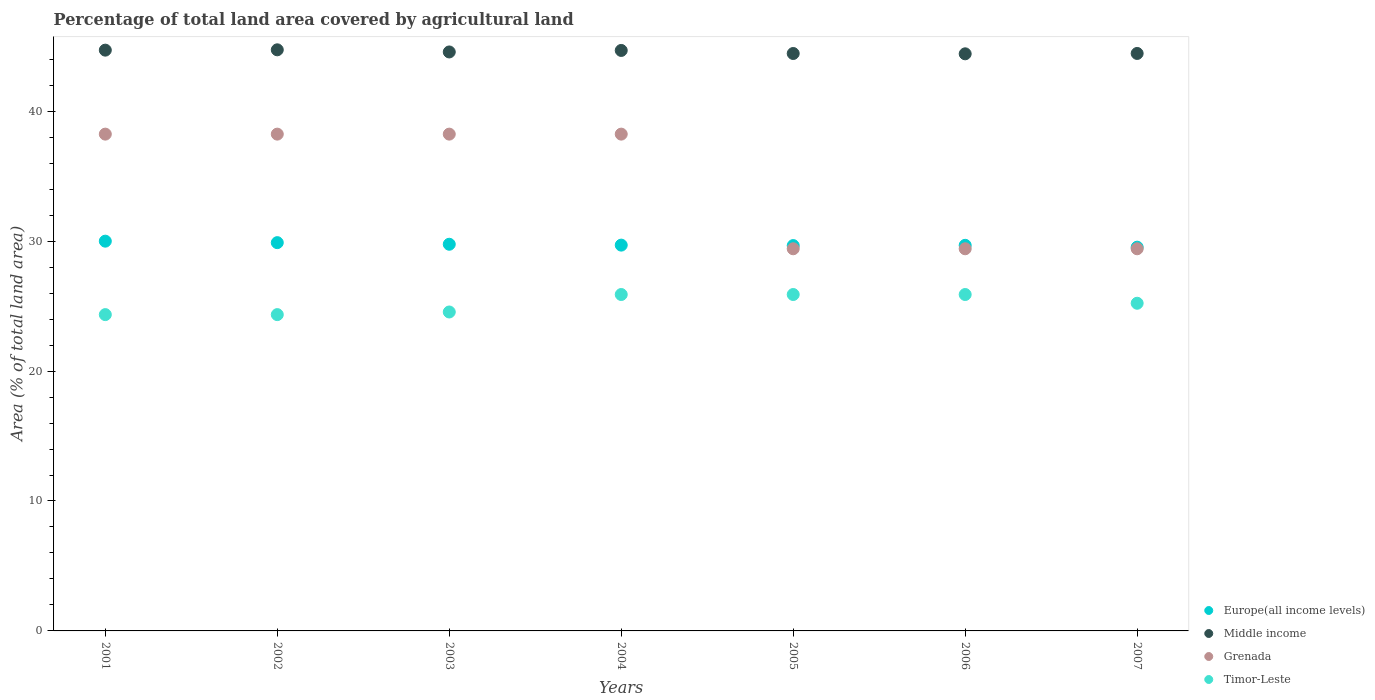How many different coloured dotlines are there?
Keep it short and to the point. 4. Is the number of dotlines equal to the number of legend labels?
Offer a very short reply. Yes. What is the percentage of agricultural land in Europe(all income levels) in 2001?
Give a very brief answer. 30. Across all years, what is the maximum percentage of agricultural land in Europe(all income levels)?
Offer a very short reply. 30. Across all years, what is the minimum percentage of agricultural land in Timor-Leste?
Offer a very short reply. 24.34. In which year was the percentage of agricultural land in Timor-Leste maximum?
Offer a very short reply. 2004. What is the total percentage of agricultural land in Grenada in the graph?
Your answer should be compact. 241.18. What is the difference between the percentage of agricultural land in Middle income in 2003 and that in 2006?
Provide a short and direct response. 0.14. What is the difference between the percentage of agricultural land in Grenada in 2006 and the percentage of agricultural land in Middle income in 2007?
Keep it short and to the point. -15.03. What is the average percentage of agricultural land in Middle income per year?
Keep it short and to the point. 44.57. In the year 2001, what is the difference between the percentage of agricultural land in Grenada and percentage of agricultural land in Europe(all income levels)?
Ensure brevity in your answer.  8.24. What is the ratio of the percentage of agricultural land in Timor-Leste in 2005 to that in 2007?
Offer a very short reply. 1.03. What is the difference between the highest and the second highest percentage of agricultural land in Middle income?
Your answer should be compact. 0.03. What is the difference between the highest and the lowest percentage of agricultural land in Middle income?
Your answer should be compact. 0.31. Is the sum of the percentage of agricultural land in Europe(all income levels) in 2003 and 2007 greater than the maximum percentage of agricultural land in Grenada across all years?
Offer a terse response. Yes. Does the percentage of agricultural land in Middle income monotonically increase over the years?
Ensure brevity in your answer.  No. Is the percentage of agricultural land in Middle income strictly greater than the percentage of agricultural land in Grenada over the years?
Offer a terse response. Yes. Is the percentage of agricultural land in Middle income strictly less than the percentage of agricultural land in Timor-Leste over the years?
Offer a terse response. No. How many years are there in the graph?
Provide a succinct answer. 7. What is the difference between two consecutive major ticks on the Y-axis?
Offer a terse response. 10. Are the values on the major ticks of Y-axis written in scientific E-notation?
Offer a very short reply. No. Where does the legend appear in the graph?
Provide a short and direct response. Bottom right. How many legend labels are there?
Your answer should be very brief. 4. What is the title of the graph?
Your response must be concise. Percentage of total land area covered by agricultural land. What is the label or title of the Y-axis?
Give a very brief answer. Area (% of total land area). What is the Area (% of total land area) of Europe(all income levels) in 2001?
Your answer should be compact. 30. What is the Area (% of total land area) in Middle income in 2001?
Make the answer very short. 44.7. What is the Area (% of total land area) of Grenada in 2001?
Offer a terse response. 38.24. What is the Area (% of total land area) in Timor-Leste in 2001?
Provide a succinct answer. 24.34. What is the Area (% of total land area) in Europe(all income levels) in 2002?
Make the answer very short. 29.88. What is the Area (% of total land area) of Middle income in 2002?
Provide a succinct answer. 44.72. What is the Area (% of total land area) in Grenada in 2002?
Keep it short and to the point. 38.24. What is the Area (% of total land area) in Timor-Leste in 2002?
Offer a very short reply. 24.34. What is the Area (% of total land area) in Europe(all income levels) in 2003?
Make the answer very short. 29.76. What is the Area (% of total land area) in Middle income in 2003?
Your answer should be very brief. 44.56. What is the Area (% of total land area) of Grenada in 2003?
Keep it short and to the point. 38.24. What is the Area (% of total land area) in Timor-Leste in 2003?
Keep it short and to the point. 24.55. What is the Area (% of total land area) in Europe(all income levels) in 2004?
Ensure brevity in your answer.  29.69. What is the Area (% of total land area) of Middle income in 2004?
Your answer should be compact. 44.68. What is the Area (% of total land area) of Grenada in 2004?
Provide a short and direct response. 38.24. What is the Area (% of total land area) of Timor-Leste in 2004?
Provide a short and direct response. 25.89. What is the Area (% of total land area) of Europe(all income levels) in 2005?
Offer a terse response. 29.66. What is the Area (% of total land area) in Middle income in 2005?
Offer a very short reply. 44.44. What is the Area (% of total land area) of Grenada in 2005?
Provide a short and direct response. 29.41. What is the Area (% of total land area) in Timor-Leste in 2005?
Keep it short and to the point. 25.89. What is the Area (% of total land area) in Europe(all income levels) in 2006?
Your answer should be very brief. 29.68. What is the Area (% of total land area) in Middle income in 2006?
Your response must be concise. 44.42. What is the Area (% of total land area) of Grenada in 2006?
Offer a terse response. 29.41. What is the Area (% of total land area) in Timor-Leste in 2006?
Provide a short and direct response. 25.89. What is the Area (% of total land area) of Europe(all income levels) in 2007?
Provide a succinct answer. 29.53. What is the Area (% of total land area) in Middle income in 2007?
Provide a succinct answer. 44.44. What is the Area (% of total land area) in Grenada in 2007?
Make the answer very short. 29.41. What is the Area (% of total land area) of Timor-Leste in 2007?
Offer a terse response. 25.22. Across all years, what is the maximum Area (% of total land area) in Europe(all income levels)?
Your answer should be very brief. 30. Across all years, what is the maximum Area (% of total land area) of Middle income?
Your answer should be very brief. 44.72. Across all years, what is the maximum Area (% of total land area) in Grenada?
Offer a terse response. 38.24. Across all years, what is the maximum Area (% of total land area) in Timor-Leste?
Make the answer very short. 25.89. Across all years, what is the minimum Area (% of total land area) of Europe(all income levels)?
Provide a short and direct response. 29.53. Across all years, what is the minimum Area (% of total land area) of Middle income?
Offer a terse response. 44.42. Across all years, what is the minimum Area (% of total land area) in Grenada?
Your answer should be compact. 29.41. Across all years, what is the minimum Area (% of total land area) of Timor-Leste?
Provide a short and direct response. 24.34. What is the total Area (% of total land area) of Europe(all income levels) in the graph?
Ensure brevity in your answer.  208.2. What is the total Area (% of total land area) in Middle income in the graph?
Your answer should be compact. 311.96. What is the total Area (% of total land area) in Grenada in the graph?
Offer a terse response. 241.18. What is the total Area (% of total land area) of Timor-Leste in the graph?
Make the answer very short. 176.13. What is the difference between the Area (% of total land area) of Europe(all income levels) in 2001 and that in 2002?
Make the answer very short. 0.11. What is the difference between the Area (% of total land area) of Middle income in 2001 and that in 2002?
Offer a terse response. -0.03. What is the difference between the Area (% of total land area) of Grenada in 2001 and that in 2002?
Provide a succinct answer. 0. What is the difference between the Area (% of total land area) of Timor-Leste in 2001 and that in 2002?
Your answer should be compact. 0. What is the difference between the Area (% of total land area) of Europe(all income levels) in 2001 and that in 2003?
Give a very brief answer. 0.24. What is the difference between the Area (% of total land area) of Middle income in 2001 and that in 2003?
Offer a very short reply. 0.14. What is the difference between the Area (% of total land area) of Grenada in 2001 and that in 2003?
Your response must be concise. 0. What is the difference between the Area (% of total land area) in Timor-Leste in 2001 and that in 2003?
Offer a terse response. -0.2. What is the difference between the Area (% of total land area) in Europe(all income levels) in 2001 and that in 2004?
Your answer should be compact. 0.3. What is the difference between the Area (% of total land area) in Middle income in 2001 and that in 2004?
Offer a very short reply. 0.02. What is the difference between the Area (% of total land area) of Grenada in 2001 and that in 2004?
Keep it short and to the point. 0. What is the difference between the Area (% of total land area) in Timor-Leste in 2001 and that in 2004?
Give a very brief answer. -1.55. What is the difference between the Area (% of total land area) in Europe(all income levels) in 2001 and that in 2005?
Give a very brief answer. 0.34. What is the difference between the Area (% of total land area) in Middle income in 2001 and that in 2005?
Give a very brief answer. 0.26. What is the difference between the Area (% of total land area) in Grenada in 2001 and that in 2005?
Your answer should be compact. 8.82. What is the difference between the Area (% of total land area) in Timor-Leste in 2001 and that in 2005?
Keep it short and to the point. -1.55. What is the difference between the Area (% of total land area) in Europe(all income levels) in 2001 and that in 2006?
Offer a very short reply. 0.32. What is the difference between the Area (% of total land area) of Middle income in 2001 and that in 2006?
Offer a very short reply. 0.28. What is the difference between the Area (% of total land area) of Grenada in 2001 and that in 2006?
Your response must be concise. 8.82. What is the difference between the Area (% of total land area) in Timor-Leste in 2001 and that in 2006?
Provide a short and direct response. -1.55. What is the difference between the Area (% of total land area) of Europe(all income levels) in 2001 and that in 2007?
Provide a short and direct response. 0.46. What is the difference between the Area (% of total land area) in Middle income in 2001 and that in 2007?
Your response must be concise. 0.25. What is the difference between the Area (% of total land area) of Grenada in 2001 and that in 2007?
Ensure brevity in your answer.  8.82. What is the difference between the Area (% of total land area) of Timor-Leste in 2001 and that in 2007?
Provide a succinct answer. -0.87. What is the difference between the Area (% of total land area) of Europe(all income levels) in 2002 and that in 2003?
Offer a terse response. 0.12. What is the difference between the Area (% of total land area) of Middle income in 2002 and that in 2003?
Make the answer very short. 0.16. What is the difference between the Area (% of total land area) of Grenada in 2002 and that in 2003?
Provide a succinct answer. 0. What is the difference between the Area (% of total land area) in Timor-Leste in 2002 and that in 2003?
Keep it short and to the point. -0.2. What is the difference between the Area (% of total land area) of Europe(all income levels) in 2002 and that in 2004?
Give a very brief answer. 0.19. What is the difference between the Area (% of total land area) of Middle income in 2002 and that in 2004?
Keep it short and to the point. 0.05. What is the difference between the Area (% of total land area) of Grenada in 2002 and that in 2004?
Ensure brevity in your answer.  0. What is the difference between the Area (% of total land area) of Timor-Leste in 2002 and that in 2004?
Offer a very short reply. -1.55. What is the difference between the Area (% of total land area) of Europe(all income levels) in 2002 and that in 2005?
Provide a succinct answer. 0.23. What is the difference between the Area (% of total land area) in Middle income in 2002 and that in 2005?
Give a very brief answer. 0.28. What is the difference between the Area (% of total land area) in Grenada in 2002 and that in 2005?
Keep it short and to the point. 8.82. What is the difference between the Area (% of total land area) of Timor-Leste in 2002 and that in 2005?
Keep it short and to the point. -1.55. What is the difference between the Area (% of total land area) in Europe(all income levels) in 2002 and that in 2006?
Your response must be concise. 0.21. What is the difference between the Area (% of total land area) of Middle income in 2002 and that in 2006?
Your answer should be very brief. 0.31. What is the difference between the Area (% of total land area) in Grenada in 2002 and that in 2006?
Keep it short and to the point. 8.82. What is the difference between the Area (% of total land area) in Timor-Leste in 2002 and that in 2006?
Offer a very short reply. -1.55. What is the difference between the Area (% of total land area) of Europe(all income levels) in 2002 and that in 2007?
Your response must be concise. 0.35. What is the difference between the Area (% of total land area) in Middle income in 2002 and that in 2007?
Offer a terse response. 0.28. What is the difference between the Area (% of total land area) of Grenada in 2002 and that in 2007?
Your answer should be compact. 8.82. What is the difference between the Area (% of total land area) in Timor-Leste in 2002 and that in 2007?
Provide a succinct answer. -0.87. What is the difference between the Area (% of total land area) of Europe(all income levels) in 2003 and that in 2004?
Your answer should be very brief. 0.07. What is the difference between the Area (% of total land area) of Middle income in 2003 and that in 2004?
Ensure brevity in your answer.  -0.12. What is the difference between the Area (% of total land area) in Timor-Leste in 2003 and that in 2004?
Provide a succinct answer. -1.34. What is the difference between the Area (% of total land area) of Europe(all income levels) in 2003 and that in 2005?
Keep it short and to the point. 0.1. What is the difference between the Area (% of total land area) in Middle income in 2003 and that in 2005?
Offer a terse response. 0.12. What is the difference between the Area (% of total land area) in Grenada in 2003 and that in 2005?
Your response must be concise. 8.82. What is the difference between the Area (% of total land area) in Timor-Leste in 2003 and that in 2005?
Your answer should be compact. -1.34. What is the difference between the Area (% of total land area) in Europe(all income levels) in 2003 and that in 2006?
Offer a very short reply. 0.08. What is the difference between the Area (% of total land area) in Middle income in 2003 and that in 2006?
Keep it short and to the point. 0.14. What is the difference between the Area (% of total land area) in Grenada in 2003 and that in 2006?
Ensure brevity in your answer.  8.82. What is the difference between the Area (% of total land area) in Timor-Leste in 2003 and that in 2006?
Offer a terse response. -1.34. What is the difference between the Area (% of total land area) in Europe(all income levels) in 2003 and that in 2007?
Your response must be concise. 0.23. What is the difference between the Area (% of total land area) of Middle income in 2003 and that in 2007?
Ensure brevity in your answer.  0.12. What is the difference between the Area (% of total land area) in Grenada in 2003 and that in 2007?
Provide a succinct answer. 8.82. What is the difference between the Area (% of total land area) of Timor-Leste in 2003 and that in 2007?
Your answer should be very brief. -0.67. What is the difference between the Area (% of total land area) of Europe(all income levels) in 2004 and that in 2005?
Your answer should be very brief. 0.04. What is the difference between the Area (% of total land area) in Middle income in 2004 and that in 2005?
Provide a short and direct response. 0.24. What is the difference between the Area (% of total land area) in Grenada in 2004 and that in 2005?
Ensure brevity in your answer.  8.82. What is the difference between the Area (% of total land area) of Timor-Leste in 2004 and that in 2005?
Give a very brief answer. 0. What is the difference between the Area (% of total land area) of Europe(all income levels) in 2004 and that in 2006?
Ensure brevity in your answer.  0.02. What is the difference between the Area (% of total land area) in Middle income in 2004 and that in 2006?
Your answer should be very brief. 0.26. What is the difference between the Area (% of total land area) of Grenada in 2004 and that in 2006?
Give a very brief answer. 8.82. What is the difference between the Area (% of total land area) of Europe(all income levels) in 2004 and that in 2007?
Provide a short and direct response. 0.16. What is the difference between the Area (% of total land area) of Middle income in 2004 and that in 2007?
Offer a very short reply. 0.23. What is the difference between the Area (% of total land area) in Grenada in 2004 and that in 2007?
Provide a succinct answer. 8.82. What is the difference between the Area (% of total land area) of Timor-Leste in 2004 and that in 2007?
Offer a very short reply. 0.67. What is the difference between the Area (% of total land area) in Europe(all income levels) in 2005 and that in 2006?
Provide a short and direct response. -0.02. What is the difference between the Area (% of total land area) in Middle income in 2005 and that in 2006?
Give a very brief answer. 0.02. What is the difference between the Area (% of total land area) of Grenada in 2005 and that in 2006?
Ensure brevity in your answer.  0. What is the difference between the Area (% of total land area) of Timor-Leste in 2005 and that in 2006?
Ensure brevity in your answer.  0. What is the difference between the Area (% of total land area) in Europe(all income levels) in 2005 and that in 2007?
Offer a very short reply. 0.12. What is the difference between the Area (% of total land area) of Middle income in 2005 and that in 2007?
Provide a short and direct response. -0. What is the difference between the Area (% of total land area) of Grenada in 2005 and that in 2007?
Give a very brief answer. 0. What is the difference between the Area (% of total land area) of Timor-Leste in 2005 and that in 2007?
Provide a short and direct response. 0.67. What is the difference between the Area (% of total land area) in Europe(all income levels) in 2006 and that in 2007?
Offer a terse response. 0.14. What is the difference between the Area (% of total land area) of Middle income in 2006 and that in 2007?
Provide a succinct answer. -0.03. What is the difference between the Area (% of total land area) of Grenada in 2006 and that in 2007?
Give a very brief answer. 0. What is the difference between the Area (% of total land area) of Timor-Leste in 2006 and that in 2007?
Offer a terse response. 0.67. What is the difference between the Area (% of total land area) in Europe(all income levels) in 2001 and the Area (% of total land area) in Middle income in 2002?
Your response must be concise. -14.73. What is the difference between the Area (% of total land area) in Europe(all income levels) in 2001 and the Area (% of total land area) in Grenada in 2002?
Offer a very short reply. -8.24. What is the difference between the Area (% of total land area) of Europe(all income levels) in 2001 and the Area (% of total land area) of Timor-Leste in 2002?
Make the answer very short. 5.65. What is the difference between the Area (% of total land area) of Middle income in 2001 and the Area (% of total land area) of Grenada in 2002?
Your response must be concise. 6.46. What is the difference between the Area (% of total land area) of Middle income in 2001 and the Area (% of total land area) of Timor-Leste in 2002?
Keep it short and to the point. 20.35. What is the difference between the Area (% of total land area) of Grenada in 2001 and the Area (% of total land area) of Timor-Leste in 2002?
Keep it short and to the point. 13.89. What is the difference between the Area (% of total land area) of Europe(all income levels) in 2001 and the Area (% of total land area) of Middle income in 2003?
Offer a very short reply. -14.56. What is the difference between the Area (% of total land area) in Europe(all income levels) in 2001 and the Area (% of total land area) in Grenada in 2003?
Make the answer very short. -8.24. What is the difference between the Area (% of total land area) in Europe(all income levels) in 2001 and the Area (% of total land area) in Timor-Leste in 2003?
Make the answer very short. 5.45. What is the difference between the Area (% of total land area) of Middle income in 2001 and the Area (% of total land area) of Grenada in 2003?
Offer a very short reply. 6.46. What is the difference between the Area (% of total land area) in Middle income in 2001 and the Area (% of total land area) in Timor-Leste in 2003?
Your response must be concise. 20.15. What is the difference between the Area (% of total land area) in Grenada in 2001 and the Area (% of total land area) in Timor-Leste in 2003?
Your answer should be very brief. 13.69. What is the difference between the Area (% of total land area) in Europe(all income levels) in 2001 and the Area (% of total land area) in Middle income in 2004?
Your answer should be very brief. -14.68. What is the difference between the Area (% of total land area) of Europe(all income levels) in 2001 and the Area (% of total land area) of Grenada in 2004?
Give a very brief answer. -8.24. What is the difference between the Area (% of total land area) of Europe(all income levels) in 2001 and the Area (% of total land area) of Timor-Leste in 2004?
Provide a short and direct response. 4.11. What is the difference between the Area (% of total land area) of Middle income in 2001 and the Area (% of total land area) of Grenada in 2004?
Make the answer very short. 6.46. What is the difference between the Area (% of total land area) of Middle income in 2001 and the Area (% of total land area) of Timor-Leste in 2004?
Your response must be concise. 18.81. What is the difference between the Area (% of total land area) in Grenada in 2001 and the Area (% of total land area) in Timor-Leste in 2004?
Keep it short and to the point. 12.34. What is the difference between the Area (% of total land area) in Europe(all income levels) in 2001 and the Area (% of total land area) in Middle income in 2005?
Provide a succinct answer. -14.44. What is the difference between the Area (% of total land area) in Europe(all income levels) in 2001 and the Area (% of total land area) in Grenada in 2005?
Offer a terse response. 0.58. What is the difference between the Area (% of total land area) in Europe(all income levels) in 2001 and the Area (% of total land area) in Timor-Leste in 2005?
Make the answer very short. 4.11. What is the difference between the Area (% of total land area) of Middle income in 2001 and the Area (% of total land area) of Grenada in 2005?
Keep it short and to the point. 15.29. What is the difference between the Area (% of total land area) of Middle income in 2001 and the Area (% of total land area) of Timor-Leste in 2005?
Ensure brevity in your answer.  18.81. What is the difference between the Area (% of total land area) in Grenada in 2001 and the Area (% of total land area) in Timor-Leste in 2005?
Your answer should be compact. 12.34. What is the difference between the Area (% of total land area) of Europe(all income levels) in 2001 and the Area (% of total land area) of Middle income in 2006?
Your answer should be compact. -14.42. What is the difference between the Area (% of total land area) in Europe(all income levels) in 2001 and the Area (% of total land area) in Grenada in 2006?
Offer a very short reply. 0.58. What is the difference between the Area (% of total land area) of Europe(all income levels) in 2001 and the Area (% of total land area) of Timor-Leste in 2006?
Your answer should be very brief. 4.11. What is the difference between the Area (% of total land area) of Middle income in 2001 and the Area (% of total land area) of Grenada in 2006?
Your response must be concise. 15.29. What is the difference between the Area (% of total land area) of Middle income in 2001 and the Area (% of total land area) of Timor-Leste in 2006?
Provide a succinct answer. 18.81. What is the difference between the Area (% of total land area) of Grenada in 2001 and the Area (% of total land area) of Timor-Leste in 2006?
Make the answer very short. 12.34. What is the difference between the Area (% of total land area) of Europe(all income levels) in 2001 and the Area (% of total land area) of Middle income in 2007?
Keep it short and to the point. -14.45. What is the difference between the Area (% of total land area) of Europe(all income levels) in 2001 and the Area (% of total land area) of Grenada in 2007?
Your answer should be very brief. 0.58. What is the difference between the Area (% of total land area) of Europe(all income levels) in 2001 and the Area (% of total land area) of Timor-Leste in 2007?
Give a very brief answer. 4.78. What is the difference between the Area (% of total land area) of Middle income in 2001 and the Area (% of total land area) of Grenada in 2007?
Keep it short and to the point. 15.29. What is the difference between the Area (% of total land area) of Middle income in 2001 and the Area (% of total land area) of Timor-Leste in 2007?
Offer a terse response. 19.48. What is the difference between the Area (% of total land area) in Grenada in 2001 and the Area (% of total land area) in Timor-Leste in 2007?
Your response must be concise. 13.02. What is the difference between the Area (% of total land area) in Europe(all income levels) in 2002 and the Area (% of total land area) in Middle income in 2003?
Offer a terse response. -14.68. What is the difference between the Area (% of total land area) of Europe(all income levels) in 2002 and the Area (% of total land area) of Grenada in 2003?
Provide a short and direct response. -8.35. What is the difference between the Area (% of total land area) in Europe(all income levels) in 2002 and the Area (% of total land area) in Timor-Leste in 2003?
Offer a very short reply. 5.34. What is the difference between the Area (% of total land area) in Middle income in 2002 and the Area (% of total land area) in Grenada in 2003?
Provide a succinct answer. 6.49. What is the difference between the Area (% of total land area) of Middle income in 2002 and the Area (% of total land area) of Timor-Leste in 2003?
Make the answer very short. 20.18. What is the difference between the Area (% of total land area) of Grenada in 2002 and the Area (% of total land area) of Timor-Leste in 2003?
Give a very brief answer. 13.69. What is the difference between the Area (% of total land area) in Europe(all income levels) in 2002 and the Area (% of total land area) in Middle income in 2004?
Provide a succinct answer. -14.79. What is the difference between the Area (% of total land area) of Europe(all income levels) in 2002 and the Area (% of total land area) of Grenada in 2004?
Your answer should be compact. -8.35. What is the difference between the Area (% of total land area) of Europe(all income levels) in 2002 and the Area (% of total land area) of Timor-Leste in 2004?
Your answer should be compact. 3.99. What is the difference between the Area (% of total land area) in Middle income in 2002 and the Area (% of total land area) in Grenada in 2004?
Your answer should be compact. 6.49. What is the difference between the Area (% of total land area) in Middle income in 2002 and the Area (% of total land area) in Timor-Leste in 2004?
Ensure brevity in your answer.  18.83. What is the difference between the Area (% of total land area) of Grenada in 2002 and the Area (% of total land area) of Timor-Leste in 2004?
Make the answer very short. 12.34. What is the difference between the Area (% of total land area) in Europe(all income levels) in 2002 and the Area (% of total land area) in Middle income in 2005?
Make the answer very short. -14.56. What is the difference between the Area (% of total land area) in Europe(all income levels) in 2002 and the Area (% of total land area) in Grenada in 2005?
Offer a terse response. 0.47. What is the difference between the Area (% of total land area) of Europe(all income levels) in 2002 and the Area (% of total land area) of Timor-Leste in 2005?
Offer a very short reply. 3.99. What is the difference between the Area (% of total land area) in Middle income in 2002 and the Area (% of total land area) in Grenada in 2005?
Make the answer very short. 15.31. What is the difference between the Area (% of total land area) in Middle income in 2002 and the Area (% of total land area) in Timor-Leste in 2005?
Provide a short and direct response. 18.83. What is the difference between the Area (% of total land area) of Grenada in 2002 and the Area (% of total land area) of Timor-Leste in 2005?
Ensure brevity in your answer.  12.34. What is the difference between the Area (% of total land area) of Europe(all income levels) in 2002 and the Area (% of total land area) of Middle income in 2006?
Ensure brevity in your answer.  -14.53. What is the difference between the Area (% of total land area) of Europe(all income levels) in 2002 and the Area (% of total land area) of Grenada in 2006?
Provide a succinct answer. 0.47. What is the difference between the Area (% of total land area) of Europe(all income levels) in 2002 and the Area (% of total land area) of Timor-Leste in 2006?
Keep it short and to the point. 3.99. What is the difference between the Area (% of total land area) of Middle income in 2002 and the Area (% of total land area) of Grenada in 2006?
Offer a terse response. 15.31. What is the difference between the Area (% of total land area) of Middle income in 2002 and the Area (% of total land area) of Timor-Leste in 2006?
Ensure brevity in your answer.  18.83. What is the difference between the Area (% of total land area) of Grenada in 2002 and the Area (% of total land area) of Timor-Leste in 2006?
Offer a very short reply. 12.34. What is the difference between the Area (% of total land area) of Europe(all income levels) in 2002 and the Area (% of total land area) of Middle income in 2007?
Provide a short and direct response. -14.56. What is the difference between the Area (% of total land area) of Europe(all income levels) in 2002 and the Area (% of total land area) of Grenada in 2007?
Your answer should be compact. 0.47. What is the difference between the Area (% of total land area) of Europe(all income levels) in 2002 and the Area (% of total land area) of Timor-Leste in 2007?
Keep it short and to the point. 4.66. What is the difference between the Area (% of total land area) in Middle income in 2002 and the Area (% of total land area) in Grenada in 2007?
Your answer should be very brief. 15.31. What is the difference between the Area (% of total land area) in Middle income in 2002 and the Area (% of total land area) in Timor-Leste in 2007?
Offer a terse response. 19.51. What is the difference between the Area (% of total land area) in Grenada in 2002 and the Area (% of total land area) in Timor-Leste in 2007?
Keep it short and to the point. 13.02. What is the difference between the Area (% of total land area) in Europe(all income levels) in 2003 and the Area (% of total land area) in Middle income in 2004?
Keep it short and to the point. -14.92. What is the difference between the Area (% of total land area) of Europe(all income levels) in 2003 and the Area (% of total land area) of Grenada in 2004?
Ensure brevity in your answer.  -8.48. What is the difference between the Area (% of total land area) in Europe(all income levels) in 2003 and the Area (% of total land area) in Timor-Leste in 2004?
Keep it short and to the point. 3.87. What is the difference between the Area (% of total land area) in Middle income in 2003 and the Area (% of total land area) in Grenada in 2004?
Keep it short and to the point. 6.32. What is the difference between the Area (% of total land area) of Middle income in 2003 and the Area (% of total land area) of Timor-Leste in 2004?
Your answer should be compact. 18.67. What is the difference between the Area (% of total land area) of Grenada in 2003 and the Area (% of total land area) of Timor-Leste in 2004?
Your answer should be very brief. 12.34. What is the difference between the Area (% of total land area) in Europe(all income levels) in 2003 and the Area (% of total land area) in Middle income in 2005?
Your answer should be very brief. -14.68. What is the difference between the Area (% of total land area) in Europe(all income levels) in 2003 and the Area (% of total land area) in Grenada in 2005?
Your answer should be compact. 0.35. What is the difference between the Area (% of total land area) in Europe(all income levels) in 2003 and the Area (% of total land area) in Timor-Leste in 2005?
Give a very brief answer. 3.87. What is the difference between the Area (% of total land area) in Middle income in 2003 and the Area (% of total land area) in Grenada in 2005?
Your answer should be compact. 15.15. What is the difference between the Area (% of total land area) in Middle income in 2003 and the Area (% of total land area) in Timor-Leste in 2005?
Offer a very short reply. 18.67. What is the difference between the Area (% of total land area) of Grenada in 2003 and the Area (% of total land area) of Timor-Leste in 2005?
Give a very brief answer. 12.34. What is the difference between the Area (% of total land area) in Europe(all income levels) in 2003 and the Area (% of total land area) in Middle income in 2006?
Make the answer very short. -14.66. What is the difference between the Area (% of total land area) in Europe(all income levels) in 2003 and the Area (% of total land area) in Grenada in 2006?
Your answer should be compact. 0.35. What is the difference between the Area (% of total land area) of Europe(all income levels) in 2003 and the Area (% of total land area) of Timor-Leste in 2006?
Offer a very short reply. 3.87. What is the difference between the Area (% of total land area) of Middle income in 2003 and the Area (% of total land area) of Grenada in 2006?
Give a very brief answer. 15.15. What is the difference between the Area (% of total land area) in Middle income in 2003 and the Area (% of total land area) in Timor-Leste in 2006?
Ensure brevity in your answer.  18.67. What is the difference between the Area (% of total land area) in Grenada in 2003 and the Area (% of total land area) in Timor-Leste in 2006?
Keep it short and to the point. 12.34. What is the difference between the Area (% of total land area) of Europe(all income levels) in 2003 and the Area (% of total land area) of Middle income in 2007?
Give a very brief answer. -14.68. What is the difference between the Area (% of total land area) in Europe(all income levels) in 2003 and the Area (% of total land area) in Grenada in 2007?
Keep it short and to the point. 0.35. What is the difference between the Area (% of total land area) in Europe(all income levels) in 2003 and the Area (% of total land area) in Timor-Leste in 2007?
Keep it short and to the point. 4.54. What is the difference between the Area (% of total land area) of Middle income in 2003 and the Area (% of total land area) of Grenada in 2007?
Give a very brief answer. 15.15. What is the difference between the Area (% of total land area) in Middle income in 2003 and the Area (% of total land area) in Timor-Leste in 2007?
Your response must be concise. 19.34. What is the difference between the Area (% of total land area) of Grenada in 2003 and the Area (% of total land area) of Timor-Leste in 2007?
Give a very brief answer. 13.02. What is the difference between the Area (% of total land area) of Europe(all income levels) in 2004 and the Area (% of total land area) of Middle income in 2005?
Your response must be concise. -14.75. What is the difference between the Area (% of total land area) in Europe(all income levels) in 2004 and the Area (% of total land area) in Grenada in 2005?
Your response must be concise. 0.28. What is the difference between the Area (% of total land area) in Europe(all income levels) in 2004 and the Area (% of total land area) in Timor-Leste in 2005?
Ensure brevity in your answer.  3.8. What is the difference between the Area (% of total land area) of Middle income in 2004 and the Area (% of total land area) of Grenada in 2005?
Provide a succinct answer. 15.26. What is the difference between the Area (% of total land area) of Middle income in 2004 and the Area (% of total land area) of Timor-Leste in 2005?
Give a very brief answer. 18.78. What is the difference between the Area (% of total land area) in Grenada in 2004 and the Area (% of total land area) in Timor-Leste in 2005?
Your response must be concise. 12.34. What is the difference between the Area (% of total land area) of Europe(all income levels) in 2004 and the Area (% of total land area) of Middle income in 2006?
Make the answer very short. -14.72. What is the difference between the Area (% of total land area) of Europe(all income levels) in 2004 and the Area (% of total land area) of Grenada in 2006?
Ensure brevity in your answer.  0.28. What is the difference between the Area (% of total land area) in Europe(all income levels) in 2004 and the Area (% of total land area) in Timor-Leste in 2006?
Offer a very short reply. 3.8. What is the difference between the Area (% of total land area) of Middle income in 2004 and the Area (% of total land area) of Grenada in 2006?
Offer a terse response. 15.26. What is the difference between the Area (% of total land area) of Middle income in 2004 and the Area (% of total land area) of Timor-Leste in 2006?
Your response must be concise. 18.78. What is the difference between the Area (% of total land area) of Grenada in 2004 and the Area (% of total land area) of Timor-Leste in 2006?
Make the answer very short. 12.34. What is the difference between the Area (% of total land area) in Europe(all income levels) in 2004 and the Area (% of total land area) in Middle income in 2007?
Offer a terse response. -14.75. What is the difference between the Area (% of total land area) of Europe(all income levels) in 2004 and the Area (% of total land area) of Grenada in 2007?
Offer a terse response. 0.28. What is the difference between the Area (% of total land area) of Europe(all income levels) in 2004 and the Area (% of total land area) of Timor-Leste in 2007?
Ensure brevity in your answer.  4.47. What is the difference between the Area (% of total land area) in Middle income in 2004 and the Area (% of total land area) in Grenada in 2007?
Offer a very short reply. 15.26. What is the difference between the Area (% of total land area) in Middle income in 2004 and the Area (% of total land area) in Timor-Leste in 2007?
Provide a short and direct response. 19.46. What is the difference between the Area (% of total land area) of Grenada in 2004 and the Area (% of total land area) of Timor-Leste in 2007?
Offer a terse response. 13.02. What is the difference between the Area (% of total land area) of Europe(all income levels) in 2005 and the Area (% of total land area) of Middle income in 2006?
Keep it short and to the point. -14.76. What is the difference between the Area (% of total land area) of Europe(all income levels) in 2005 and the Area (% of total land area) of Grenada in 2006?
Give a very brief answer. 0.25. What is the difference between the Area (% of total land area) of Europe(all income levels) in 2005 and the Area (% of total land area) of Timor-Leste in 2006?
Your answer should be compact. 3.77. What is the difference between the Area (% of total land area) of Middle income in 2005 and the Area (% of total land area) of Grenada in 2006?
Keep it short and to the point. 15.03. What is the difference between the Area (% of total land area) of Middle income in 2005 and the Area (% of total land area) of Timor-Leste in 2006?
Keep it short and to the point. 18.55. What is the difference between the Area (% of total land area) of Grenada in 2005 and the Area (% of total land area) of Timor-Leste in 2006?
Keep it short and to the point. 3.52. What is the difference between the Area (% of total land area) in Europe(all income levels) in 2005 and the Area (% of total land area) in Middle income in 2007?
Offer a very short reply. -14.79. What is the difference between the Area (% of total land area) in Europe(all income levels) in 2005 and the Area (% of total land area) in Grenada in 2007?
Your response must be concise. 0.25. What is the difference between the Area (% of total land area) in Europe(all income levels) in 2005 and the Area (% of total land area) in Timor-Leste in 2007?
Offer a very short reply. 4.44. What is the difference between the Area (% of total land area) in Middle income in 2005 and the Area (% of total land area) in Grenada in 2007?
Your response must be concise. 15.03. What is the difference between the Area (% of total land area) of Middle income in 2005 and the Area (% of total land area) of Timor-Leste in 2007?
Give a very brief answer. 19.22. What is the difference between the Area (% of total land area) in Grenada in 2005 and the Area (% of total land area) in Timor-Leste in 2007?
Offer a terse response. 4.19. What is the difference between the Area (% of total land area) of Europe(all income levels) in 2006 and the Area (% of total land area) of Middle income in 2007?
Your answer should be very brief. -14.77. What is the difference between the Area (% of total land area) of Europe(all income levels) in 2006 and the Area (% of total land area) of Grenada in 2007?
Your response must be concise. 0.27. What is the difference between the Area (% of total land area) of Europe(all income levels) in 2006 and the Area (% of total land area) of Timor-Leste in 2007?
Make the answer very short. 4.46. What is the difference between the Area (% of total land area) in Middle income in 2006 and the Area (% of total land area) in Grenada in 2007?
Provide a succinct answer. 15. What is the difference between the Area (% of total land area) of Middle income in 2006 and the Area (% of total land area) of Timor-Leste in 2007?
Ensure brevity in your answer.  19.2. What is the difference between the Area (% of total land area) of Grenada in 2006 and the Area (% of total land area) of Timor-Leste in 2007?
Offer a terse response. 4.19. What is the average Area (% of total land area) in Europe(all income levels) per year?
Ensure brevity in your answer.  29.74. What is the average Area (% of total land area) in Middle income per year?
Make the answer very short. 44.57. What is the average Area (% of total land area) of Grenada per year?
Make the answer very short. 34.45. What is the average Area (% of total land area) in Timor-Leste per year?
Your answer should be compact. 25.16. In the year 2001, what is the difference between the Area (% of total land area) of Europe(all income levels) and Area (% of total land area) of Middle income?
Offer a terse response. -14.7. In the year 2001, what is the difference between the Area (% of total land area) in Europe(all income levels) and Area (% of total land area) in Grenada?
Offer a terse response. -8.24. In the year 2001, what is the difference between the Area (% of total land area) in Europe(all income levels) and Area (% of total land area) in Timor-Leste?
Keep it short and to the point. 5.65. In the year 2001, what is the difference between the Area (% of total land area) in Middle income and Area (% of total land area) in Grenada?
Offer a very short reply. 6.46. In the year 2001, what is the difference between the Area (% of total land area) in Middle income and Area (% of total land area) in Timor-Leste?
Keep it short and to the point. 20.35. In the year 2001, what is the difference between the Area (% of total land area) in Grenada and Area (% of total land area) in Timor-Leste?
Provide a succinct answer. 13.89. In the year 2002, what is the difference between the Area (% of total land area) in Europe(all income levels) and Area (% of total land area) in Middle income?
Your answer should be compact. -14.84. In the year 2002, what is the difference between the Area (% of total land area) of Europe(all income levels) and Area (% of total land area) of Grenada?
Offer a very short reply. -8.35. In the year 2002, what is the difference between the Area (% of total land area) of Europe(all income levels) and Area (% of total land area) of Timor-Leste?
Your answer should be compact. 5.54. In the year 2002, what is the difference between the Area (% of total land area) in Middle income and Area (% of total land area) in Grenada?
Your answer should be compact. 6.49. In the year 2002, what is the difference between the Area (% of total land area) in Middle income and Area (% of total land area) in Timor-Leste?
Provide a short and direct response. 20.38. In the year 2002, what is the difference between the Area (% of total land area) of Grenada and Area (% of total land area) of Timor-Leste?
Keep it short and to the point. 13.89. In the year 2003, what is the difference between the Area (% of total land area) in Europe(all income levels) and Area (% of total land area) in Middle income?
Give a very brief answer. -14.8. In the year 2003, what is the difference between the Area (% of total land area) of Europe(all income levels) and Area (% of total land area) of Grenada?
Your answer should be compact. -8.48. In the year 2003, what is the difference between the Area (% of total land area) in Europe(all income levels) and Area (% of total land area) in Timor-Leste?
Your response must be concise. 5.21. In the year 2003, what is the difference between the Area (% of total land area) of Middle income and Area (% of total land area) of Grenada?
Your response must be concise. 6.32. In the year 2003, what is the difference between the Area (% of total land area) of Middle income and Area (% of total land area) of Timor-Leste?
Ensure brevity in your answer.  20.01. In the year 2003, what is the difference between the Area (% of total land area) in Grenada and Area (% of total land area) in Timor-Leste?
Offer a very short reply. 13.69. In the year 2004, what is the difference between the Area (% of total land area) in Europe(all income levels) and Area (% of total land area) in Middle income?
Keep it short and to the point. -14.98. In the year 2004, what is the difference between the Area (% of total land area) in Europe(all income levels) and Area (% of total land area) in Grenada?
Ensure brevity in your answer.  -8.54. In the year 2004, what is the difference between the Area (% of total land area) of Europe(all income levels) and Area (% of total land area) of Timor-Leste?
Your answer should be compact. 3.8. In the year 2004, what is the difference between the Area (% of total land area) in Middle income and Area (% of total land area) in Grenada?
Your answer should be compact. 6.44. In the year 2004, what is the difference between the Area (% of total land area) in Middle income and Area (% of total land area) in Timor-Leste?
Offer a very short reply. 18.78. In the year 2004, what is the difference between the Area (% of total land area) of Grenada and Area (% of total land area) of Timor-Leste?
Ensure brevity in your answer.  12.34. In the year 2005, what is the difference between the Area (% of total land area) in Europe(all income levels) and Area (% of total land area) in Middle income?
Your answer should be compact. -14.78. In the year 2005, what is the difference between the Area (% of total land area) in Europe(all income levels) and Area (% of total land area) in Grenada?
Provide a short and direct response. 0.25. In the year 2005, what is the difference between the Area (% of total land area) of Europe(all income levels) and Area (% of total land area) of Timor-Leste?
Your response must be concise. 3.77. In the year 2005, what is the difference between the Area (% of total land area) of Middle income and Area (% of total land area) of Grenada?
Provide a succinct answer. 15.03. In the year 2005, what is the difference between the Area (% of total land area) in Middle income and Area (% of total land area) in Timor-Leste?
Your answer should be compact. 18.55. In the year 2005, what is the difference between the Area (% of total land area) in Grenada and Area (% of total land area) in Timor-Leste?
Offer a very short reply. 3.52. In the year 2006, what is the difference between the Area (% of total land area) in Europe(all income levels) and Area (% of total land area) in Middle income?
Give a very brief answer. -14.74. In the year 2006, what is the difference between the Area (% of total land area) in Europe(all income levels) and Area (% of total land area) in Grenada?
Your response must be concise. 0.27. In the year 2006, what is the difference between the Area (% of total land area) in Europe(all income levels) and Area (% of total land area) in Timor-Leste?
Your response must be concise. 3.79. In the year 2006, what is the difference between the Area (% of total land area) of Middle income and Area (% of total land area) of Grenada?
Provide a succinct answer. 15. In the year 2006, what is the difference between the Area (% of total land area) of Middle income and Area (% of total land area) of Timor-Leste?
Offer a terse response. 18.53. In the year 2006, what is the difference between the Area (% of total land area) of Grenada and Area (% of total land area) of Timor-Leste?
Offer a very short reply. 3.52. In the year 2007, what is the difference between the Area (% of total land area) of Europe(all income levels) and Area (% of total land area) of Middle income?
Ensure brevity in your answer.  -14.91. In the year 2007, what is the difference between the Area (% of total land area) of Europe(all income levels) and Area (% of total land area) of Grenada?
Your response must be concise. 0.12. In the year 2007, what is the difference between the Area (% of total land area) in Europe(all income levels) and Area (% of total land area) in Timor-Leste?
Give a very brief answer. 4.32. In the year 2007, what is the difference between the Area (% of total land area) in Middle income and Area (% of total land area) in Grenada?
Your answer should be very brief. 15.03. In the year 2007, what is the difference between the Area (% of total land area) in Middle income and Area (% of total land area) in Timor-Leste?
Your answer should be compact. 19.23. In the year 2007, what is the difference between the Area (% of total land area) in Grenada and Area (% of total land area) in Timor-Leste?
Your response must be concise. 4.19. What is the ratio of the Area (% of total land area) in Middle income in 2001 to that in 2002?
Your response must be concise. 1. What is the ratio of the Area (% of total land area) in Grenada in 2001 to that in 2002?
Your answer should be very brief. 1. What is the ratio of the Area (% of total land area) in Timor-Leste in 2001 to that in 2002?
Your answer should be very brief. 1. What is the ratio of the Area (% of total land area) of Europe(all income levels) in 2001 to that in 2003?
Offer a terse response. 1.01. What is the ratio of the Area (% of total land area) in Middle income in 2001 to that in 2003?
Give a very brief answer. 1. What is the ratio of the Area (% of total land area) in Grenada in 2001 to that in 2003?
Ensure brevity in your answer.  1. What is the ratio of the Area (% of total land area) of Timor-Leste in 2001 to that in 2003?
Make the answer very short. 0.99. What is the ratio of the Area (% of total land area) of Europe(all income levels) in 2001 to that in 2004?
Ensure brevity in your answer.  1.01. What is the ratio of the Area (% of total land area) of Timor-Leste in 2001 to that in 2004?
Your answer should be very brief. 0.94. What is the ratio of the Area (% of total land area) in Europe(all income levels) in 2001 to that in 2005?
Give a very brief answer. 1.01. What is the ratio of the Area (% of total land area) in Grenada in 2001 to that in 2005?
Ensure brevity in your answer.  1.3. What is the ratio of the Area (% of total land area) of Timor-Leste in 2001 to that in 2005?
Make the answer very short. 0.94. What is the ratio of the Area (% of total land area) of Europe(all income levels) in 2001 to that in 2006?
Make the answer very short. 1.01. What is the ratio of the Area (% of total land area) in Middle income in 2001 to that in 2006?
Your answer should be compact. 1.01. What is the ratio of the Area (% of total land area) of Grenada in 2001 to that in 2006?
Provide a succinct answer. 1.3. What is the ratio of the Area (% of total land area) of Timor-Leste in 2001 to that in 2006?
Keep it short and to the point. 0.94. What is the ratio of the Area (% of total land area) of Europe(all income levels) in 2001 to that in 2007?
Ensure brevity in your answer.  1.02. What is the ratio of the Area (% of total land area) of Middle income in 2001 to that in 2007?
Provide a short and direct response. 1.01. What is the ratio of the Area (% of total land area) in Grenada in 2001 to that in 2007?
Your answer should be very brief. 1.3. What is the ratio of the Area (% of total land area) of Timor-Leste in 2001 to that in 2007?
Provide a short and direct response. 0.97. What is the ratio of the Area (% of total land area) of Timor-Leste in 2002 to that in 2003?
Your answer should be very brief. 0.99. What is the ratio of the Area (% of total land area) in Europe(all income levels) in 2002 to that in 2004?
Keep it short and to the point. 1.01. What is the ratio of the Area (% of total land area) of Timor-Leste in 2002 to that in 2004?
Provide a short and direct response. 0.94. What is the ratio of the Area (% of total land area) of Europe(all income levels) in 2002 to that in 2005?
Provide a succinct answer. 1.01. What is the ratio of the Area (% of total land area) of Middle income in 2002 to that in 2005?
Offer a very short reply. 1.01. What is the ratio of the Area (% of total land area) in Grenada in 2002 to that in 2005?
Your response must be concise. 1.3. What is the ratio of the Area (% of total land area) in Timor-Leste in 2002 to that in 2005?
Your answer should be very brief. 0.94. What is the ratio of the Area (% of total land area) in Europe(all income levels) in 2002 to that in 2006?
Give a very brief answer. 1.01. What is the ratio of the Area (% of total land area) in Grenada in 2002 to that in 2006?
Offer a very short reply. 1.3. What is the ratio of the Area (% of total land area) of Timor-Leste in 2002 to that in 2006?
Ensure brevity in your answer.  0.94. What is the ratio of the Area (% of total land area) of Europe(all income levels) in 2002 to that in 2007?
Offer a terse response. 1.01. What is the ratio of the Area (% of total land area) in Middle income in 2002 to that in 2007?
Your answer should be very brief. 1.01. What is the ratio of the Area (% of total land area) in Grenada in 2002 to that in 2007?
Offer a terse response. 1.3. What is the ratio of the Area (% of total land area) of Timor-Leste in 2002 to that in 2007?
Provide a succinct answer. 0.97. What is the ratio of the Area (% of total land area) of Timor-Leste in 2003 to that in 2004?
Offer a terse response. 0.95. What is the ratio of the Area (% of total land area) in Europe(all income levels) in 2003 to that in 2005?
Make the answer very short. 1. What is the ratio of the Area (% of total land area) of Middle income in 2003 to that in 2005?
Ensure brevity in your answer.  1. What is the ratio of the Area (% of total land area) in Grenada in 2003 to that in 2005?
Ensure brevity in your answer.  1.3. What is the ratio of the Area (% of total land area) of Timor-Leste in 2003 to that in 2005?
Make the answer very short. 0.95. What is the ratio of the Area (% of total land area) of Grenada in 2003 to that in 2006?
Your answer should be compact. 1.3. What is the ratio of the Area (% of total land area) of Timor-Leste in 2003 to that in 2006?
Offer a very short reply. 0.95. What is the ratio of the Area (% of total land area) of Europe(all income levels) in 2003 to that in 2007?
Give a very brief answer. 1.01. What is the ratio of the Area (% of total land area) of Timor-Leste in 2003 to that in 2007?
Keep it short and to the point. 0.97. What is the ratio of the Area (% of total land area) of Middle income in 2004 to that in 2005?
Keep it short and to the point. 1.01. What is the ratio of the Area (% of total land area) of Grenada in 2004 to that in 2005?
Offer a very short reply. 1.3. What is the ratio of the Area (% of total land area) of Timor-Leste in 2004 to that in 2006?
Keep it short and to the point. 1. What is the ratio of the Area (% of total land area) of Europe(all income levels) in 2004 to that in 2007?
Offer a very short reply. 1.01. What is the ratio of the Area (% of total land area) of Middle income in 2004 to that in 2007?
Ensure brevity in your answer.  1.01. What is the ratio of the Area (% of total land area) in Grenada in 2004 to that in 2007?
Provide a succinct answer. 1.3. What is the ratio of the Area (% of total land area) of Timor-Leste in 2004 to that in 2007?
Ensure brevity in your answer.  1.03. What is the ratio of the Area (% of total land area) in Grenada in 2005 to that in 2006?
Offer a terse response. 1. What is the ratio of the Area (% of total land area) of Timor-Leste in 2005 to that in 2006?
Your answer should be very brief. 1. What is the ratio of the Area (% of total land area) of Timor-Leste in 2005 to that in 2007?
Provide a short and direct response. 1.03. What is the ratio of the Area (% of total land area) in Middle income in 2006 to that in 2007?
Make the answer very short. 1. What is the ratio of the Area (% of total land area) of Timor-Leste in 2006 to that in 2007?
Make the answer very short. 1.03. What is the difference between the highest and the second highest Area (% of total land area) in Europe(all income levels)?
Provide a succinct answer. 0.11. What is the difference between the highest and the second highest Area (% of total land area) in Middle income?
Keep it short and to the point. 0.03. What is the difference between the highest and the second highest Area (% of total land area) in Grenada?
Ensure brevity in your answer.  0. What is the difference between the highest and the second highest Area (% of total land area) of Timor-Leste?
Offer a very short reply. 0. What is the difference between the highest and the lowest Area (% of total land area) in Europe(all income levels)?
Provide a succinct answer. 0.46. What is the difference between the highest and the lowest Area (% of total land area) in Middle income?
Keep it short and to the point. 0.31. What is the difference between the highest and the lowest Area (% of total land area) of Grenada?
Offer a very short reply. 8.82. What is the difference between the highest and the lowest Area (% of total land area) in Timor-Leste?
Give a very brief answer. 1.55. 